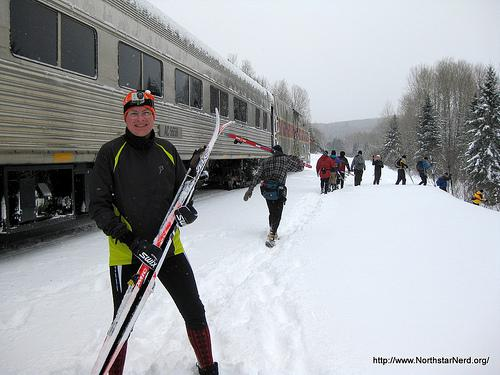Question: when is this scene occurring?
Choices:
A. Late morning.
B. Early evening.
C. Noon.
D. Midnight.
Answer with the letter. Answer: B Question: how is the weather?
Choices:
A. Clear and cold.
B. Windy and cold.
C. Sunny and hot.
D. Rainy and cold.
Answer with the letter. Answer: A Question: who is facing the camera?
Choices:
A. A woman in polka dot red  and white dress.
B. A man in black and yellow ski suit.
C. A woman in an ivory wedding dress.
D. A man in black and white tuxedo.
Answer with the letter. Answer: B Question: what is to the left of the people?
Choices:
A. Car.
B. Bus.
C. Train.
D. Building.
Answer with the letter. Answer: C 